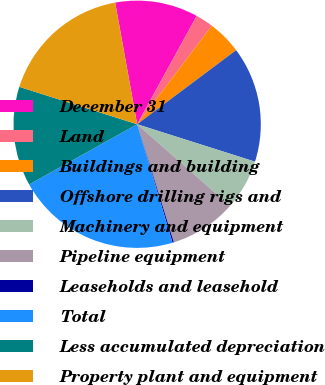Convert chart. <chart><loc_0><loc_0><loc_500><loc_500><pie_chart><fcel>December 31<fcel>Land<fcel>Buildings and building<fcel>Offshore drilling rigs and<fcel>Machinery and equipment<fcel>Pipeline equipment<fcel>Leaseholds and leasehold<fcel>Total<fcel>Less accumulated depreciation<fcel>Property plant and equipment<nl><fcel>10.85%<fcel>2.32%<fcel>4.45%<fcel>15.12%<fcel>6.59%<fcel>8.72%<fcel>0.18%<fcel>21.52%<fcel>12.99%<fcel>17.26%<nl></chart> 